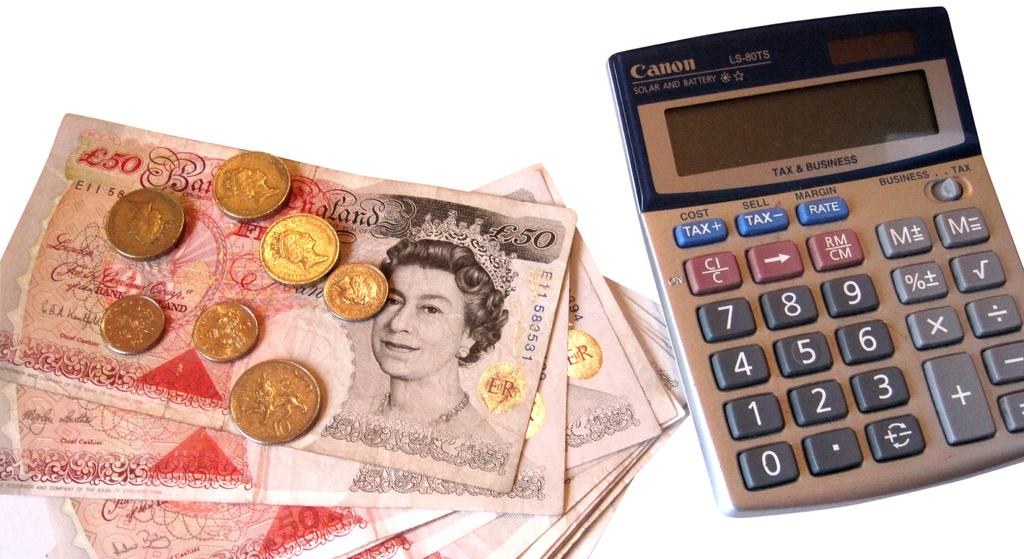<image>
Relay a brief, clear account of the picture shown. A pile of notes and coins next to a Canon brand calculator. 